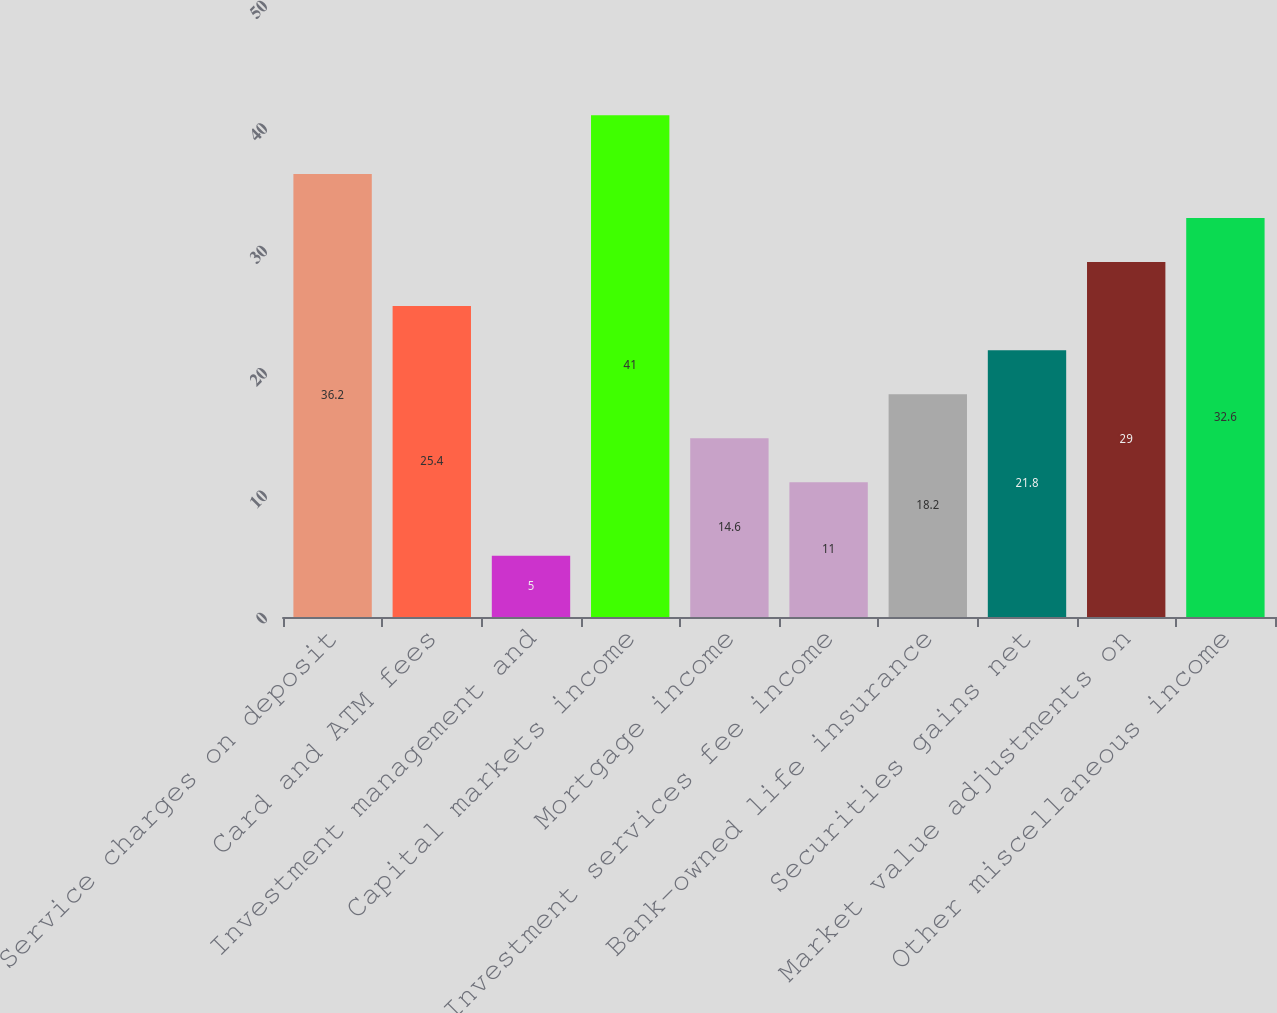<chart> <loc_0><loc_0><loc_500><loc_500><bar_chart><fcel>Service charges on deposit<fcel>Card and ATM fees<fcel>Investment management and<fcel>Capital markets income<fcel>Mortgage income<fcel>Investment services fee income<fcel>Bank-owned life insurance<fcel>Securities gains net<fcel>Market value adjustments on<fcel>Other miscellaneous income<nl><fcel>36.2<fcel>25.4<fcel>5<fcel>41<fcel>14.6<fcel>11<fcel>18.2<fcel>21.8<fcel>29<fcel>32.6<nl></chart> 